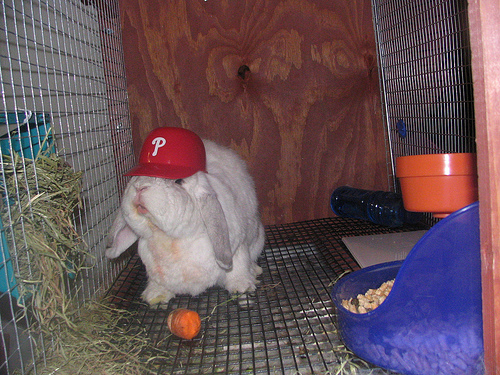<image>
Can you confirm if the hat is on the rabbit? Yes. Looking at the image, I can see the hat is positioned on top of the rabbit, with the rabbit providing support. Is there a rabbit under the fence? No. The rabbit is not positioned under the fence. The vertical relationship between these objects is different. Where is the hat in relation to the rabbit? Is it above the rabbit? No. The hat is not positioned above the rabbit. The vertical arrangement shows a different relationship. 